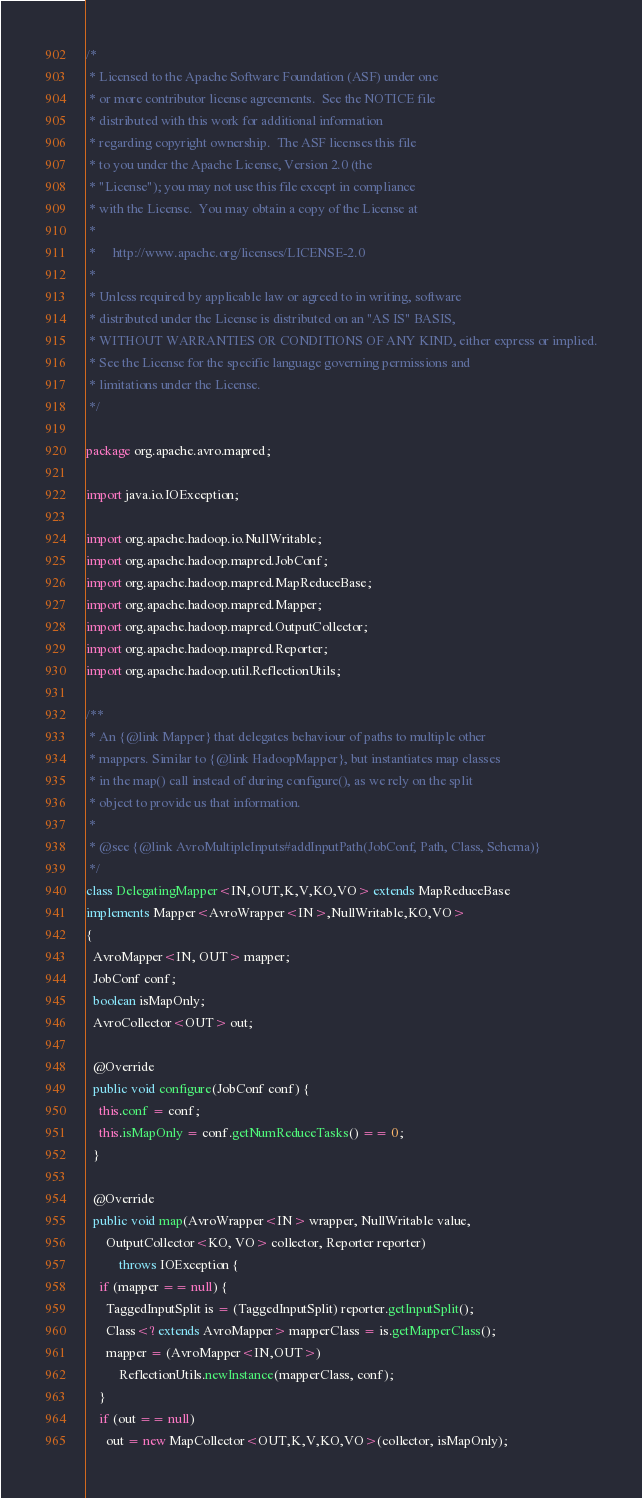<code> <loc_0><loc_0><loc_500><loc_500><_Java_>/*
 * Licensed to the Apache Software Foundation (ASF) under one
 * or more contributor license agreements.  See the NOTICE file
 * distributed with this work for additional information
 * regarding copyright ownership.  The ASF licenses this file
 * to you under the Apache License, Version 2.0 (the
 * "License"); you may not use this file except in compliance
 * with the License.  You may obtain a copy of the License at
 *
 *     http://www.apache.org/licenses/LICENSE-2.0
 *
 * Unless required by applicable law or agreed to in writing, software
 * distributed under the License is distributed on an "AS IS" BASIS,
 * WITHOUT WARRANTIES OR CONDITIONS OF ANY KIND, either express or implied.
 * See the License for the specific language governing permissions and
 * limitations under the License.
 */

package org.apache.avro.mapred;

import java.io.IOException;

import org.apache.hadoop.io.NullWritable;
import org.apache.hadoop.mapred.JobConf;
import org.apache.hadoop.mapred.MapReduceBase;
import org.apache.hadoop.mapred.Mapper;
import org.apache.hadoop.mapred.OutputCollector;
import org.apache.hadoop.mapred.Reporter;
import org.apache.hadoop.util.ReflectionUtils;

/**
 * An {@link Mapper} that delegates behaviour of paths to multiple other
 * mappers. Similar to {@link HadoopMapper}, but instantiates map classes
 * in the map() call instead of during configure(), as we rely on the split
 * object to provide us that information.
 *
 * @see {@link AvroMultipleInputs#addInputPath(JobConf, Path, Class, Schema)}
 */
class DelegatingMapper<IN,OUT,K,V,KO,VO> extends MapReduceBase
implements Mapper<AvroWrapper<IN>,NullWritable,KO,VO>
{
  AvroMapper<IN, OUT> mapper;
  JobConf conf;
  boolean isMapOnly;
  AvroCollector<OUT> out;

  @Override
  public void configure(JobConf conf) {
    this.conf = conf;
    this.isMapOnly = conf.getNumReduceTasks() == 0;
  }

  @Override
  public void map(AvroWrapper<IN> wrapper, NullWritable value,
      OutputCollector<KO, VO> collector, Reporter reporter)
          throws IOException {
    if (mapper == null) {
      TaggedInputSplit is = (TaggedInputSplit) reporter.getInputSplit();
      Class<? extends AvroMapper> mapperClass = is.getMapperClass();
      mapper = (AvroMapper<IN,OUT>)
          ReflectionUtils.newInstance(mapperClass, conf);
    }
    if (out == null)
      out = new MapCollector<OUT,K,V,KO,VO>(collector, isMapOnly);</code> 